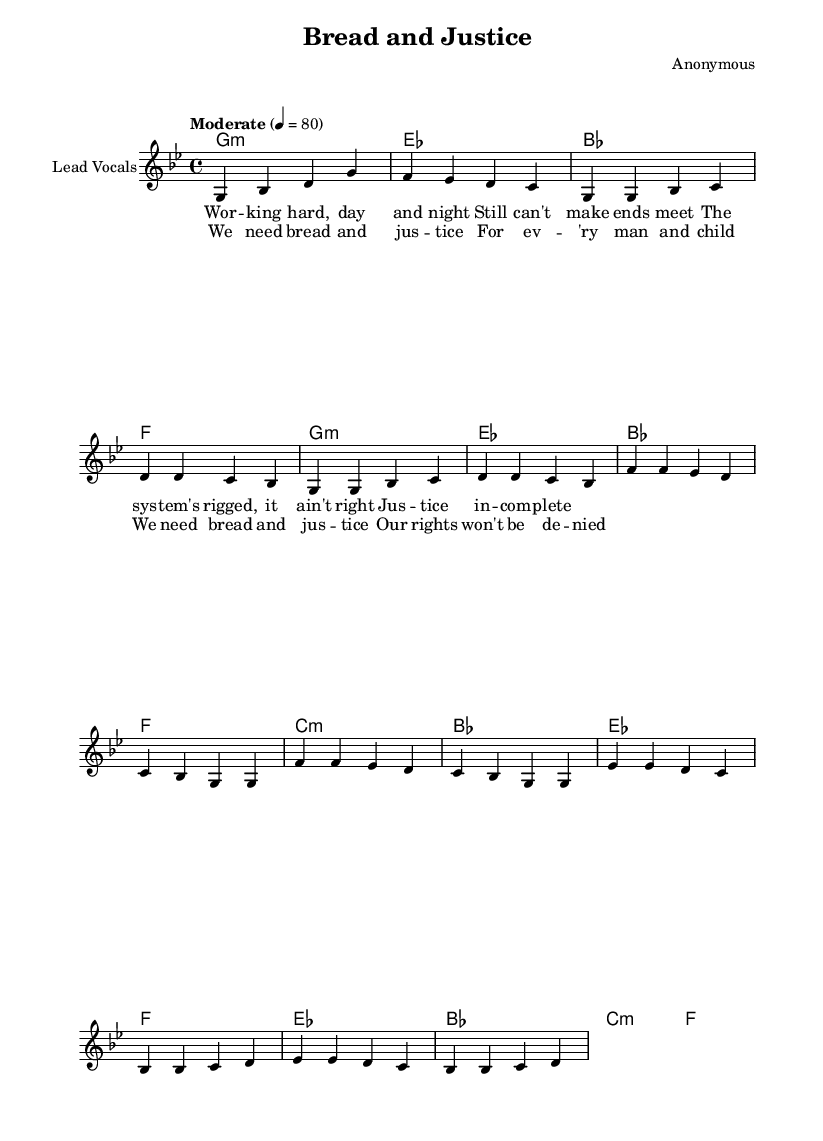What is the key signature of this music? The key signature displayed at the beginning of the piece indicates G minor, which has two flats (B flat and E flat).
Answer: G minor What is the time signature of this piece? The time signature appears at the beginning as 4/4, which means there are four beats in each measure, and a quarter note gets one beat.
Answer: 4/4 What is the tempo marking for this song? The tempo marking shows "Moderate" with a metronome marking of 80 beats per minute, indicating a moderately paced tempo for the piece.
Answer: Moderate 4 = 80 How many measures are in the chorus? By counting the measures for the chorus section, it is observed that there are four measures total as the melody and lyrics align with the structure of the chorus.
Answer: 4 What is the main theme highlighted in the lyrics? The lyrics discuss struggles for economic justice and the need for fairness in society, reflecting the broader civil rights movement themes of the time.
Answer: Bread and justice Which section comes after the verse? The structure of the piece implies that the chorus follows the verse, as indicated by the layout and musical progression outlined in the sheet music.
Answer: Chorus What type of musical piece is this? This piece is categorized under soul music, a style that is significant in expressing emotional and social themes relevant to the civil rights era.
Answer: Soul music 